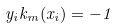Convert formula to latex. <formula><loc_0><loc_0><loc_500><loc_500>y _ { i } k _ { m } ( x _ { i } ) = - 1</formula> 